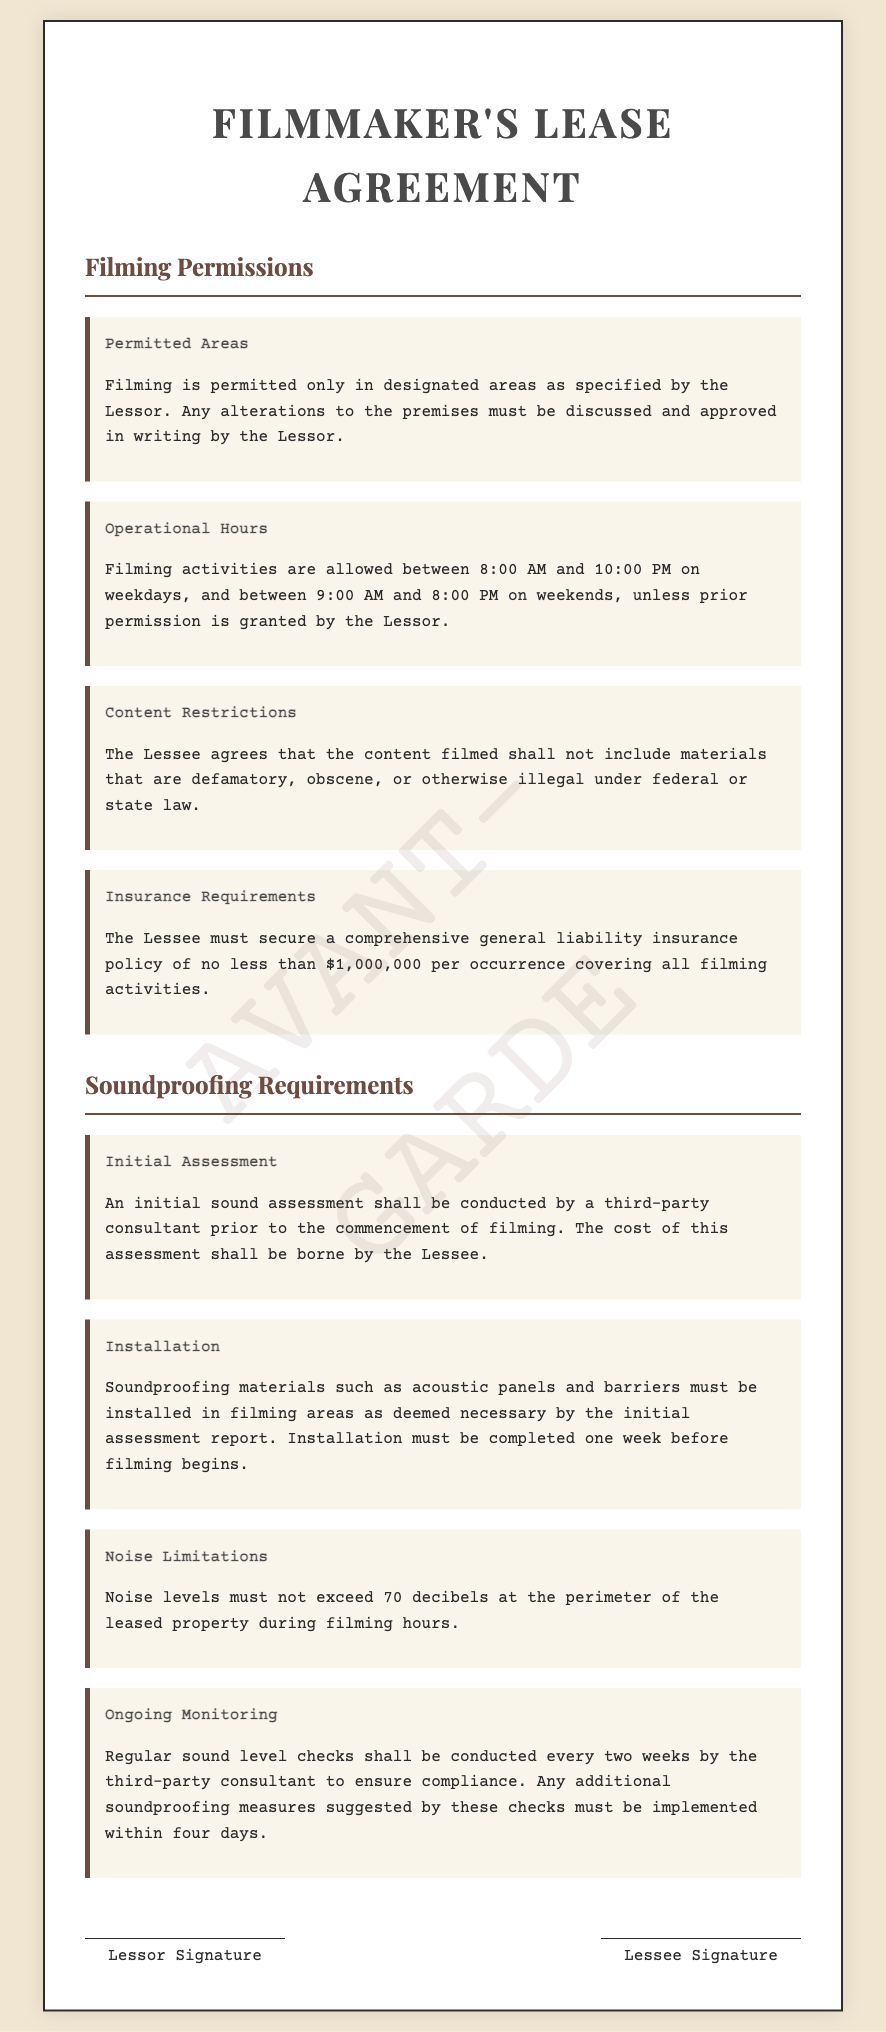What are the permitted filming hours on weekdays? The document specifies that filming activities are allowed between 8:00 AM and 10:00 PM on weekdays.
Answer: 8:00 AM to 10:00 PM Who bears the cost of the initial sound assessment? According to the document, the cost of the initial sound assessment shall be borne by the Lessee.
Answer: Lessee What is the noise limit during filming hours at the perimeter of the property? The document states that noise levels must not exceed 70 decibels at the perimeter of the leased property during filming hours.
Answer: 70 decibels What type of insurance is required for filming activities? The Lessee must secure a comprehensive general liability insurance policy of no less than $1,000,000 per occurrence.
Answer: $1,000,000 How often shall regular sound level checks be conducted? The document mentions that regular sound level checks shall be conducted every two weeks by the third-party consultant.
Answer: Every two weeks What is the deadline for soundproofing installation prior to filming? The installation of soundproofing materials must be completed one week before filming begins.
Answer: One week before filming 